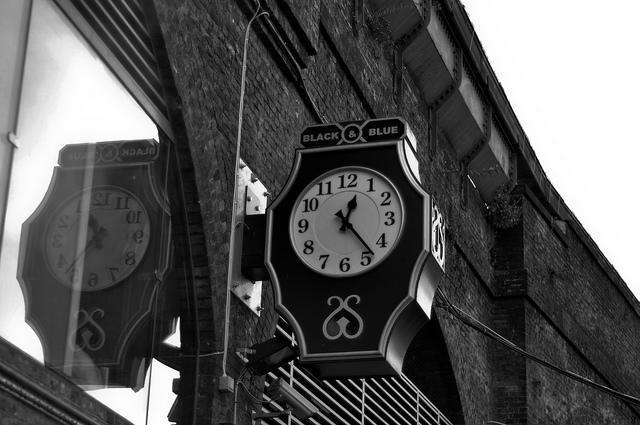How many clocks are there?
Give a very brief answer. 2. 